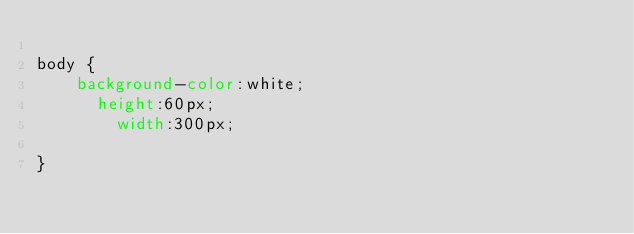<code> <loc_0><loc_0><loc_500><loc_500><_CSS_>
body {
    background-color:white;
      height:60px;
        width:300px;

}
</code> 